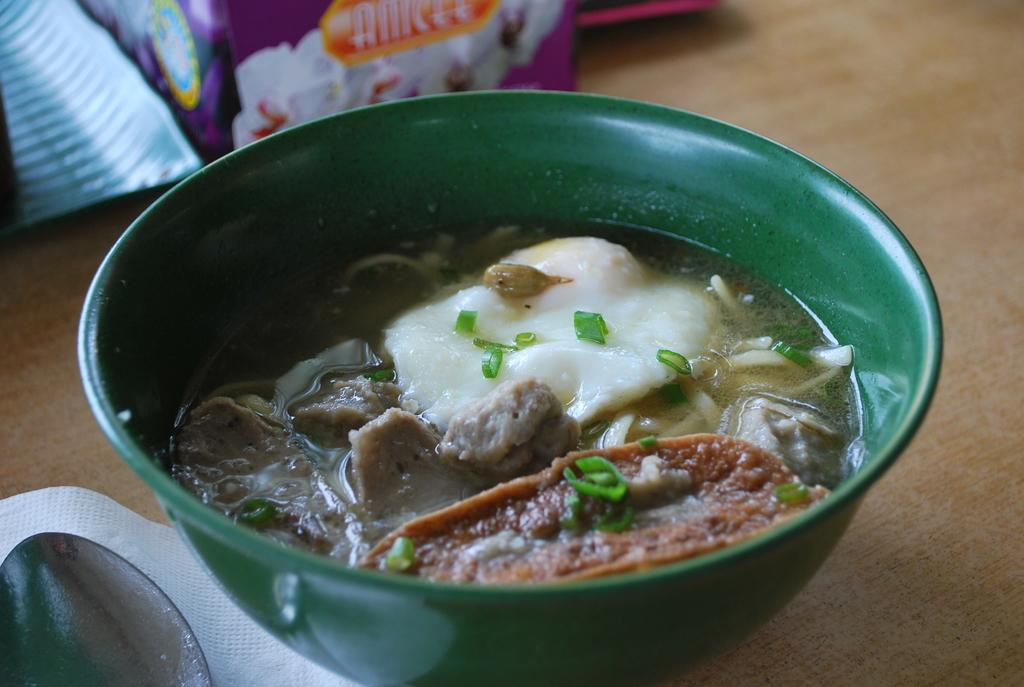What is in the bowl that is visible in the image? There is food in a bowl in the image. What can be used to clean or wipe in the image? There is tissue paper in the image. What utensil is visible in the image? There is a spoon in the image. What is the surface on which the packets are placed in the image? There are packets on a wooden platform in the image. What degree does the oil have in the image? There is no oil present in the image, so it is not possible to determine its degree. 